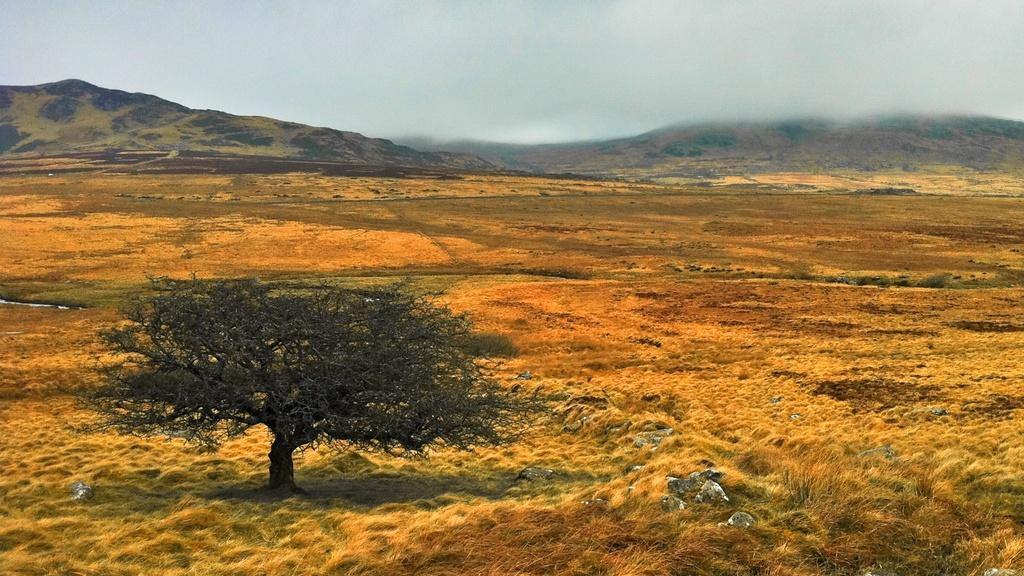What type of vegetation is present in the image? There is a tree in the image. What other objects can be seen on the ground in the image? There are stones in the image. What type of landscape feature is visible in the image? There are mountains in the image. What is visible in the background of the image? The sky is visible in the background of the image. What can be observed in the sky? Clouds are present in the sky. What type of juice is being served in the image? There is no juice present in the image; it features a tree, stones, mountains, and a sky with clouds. What arm is visible in the image? There are no arms visible in the image. 